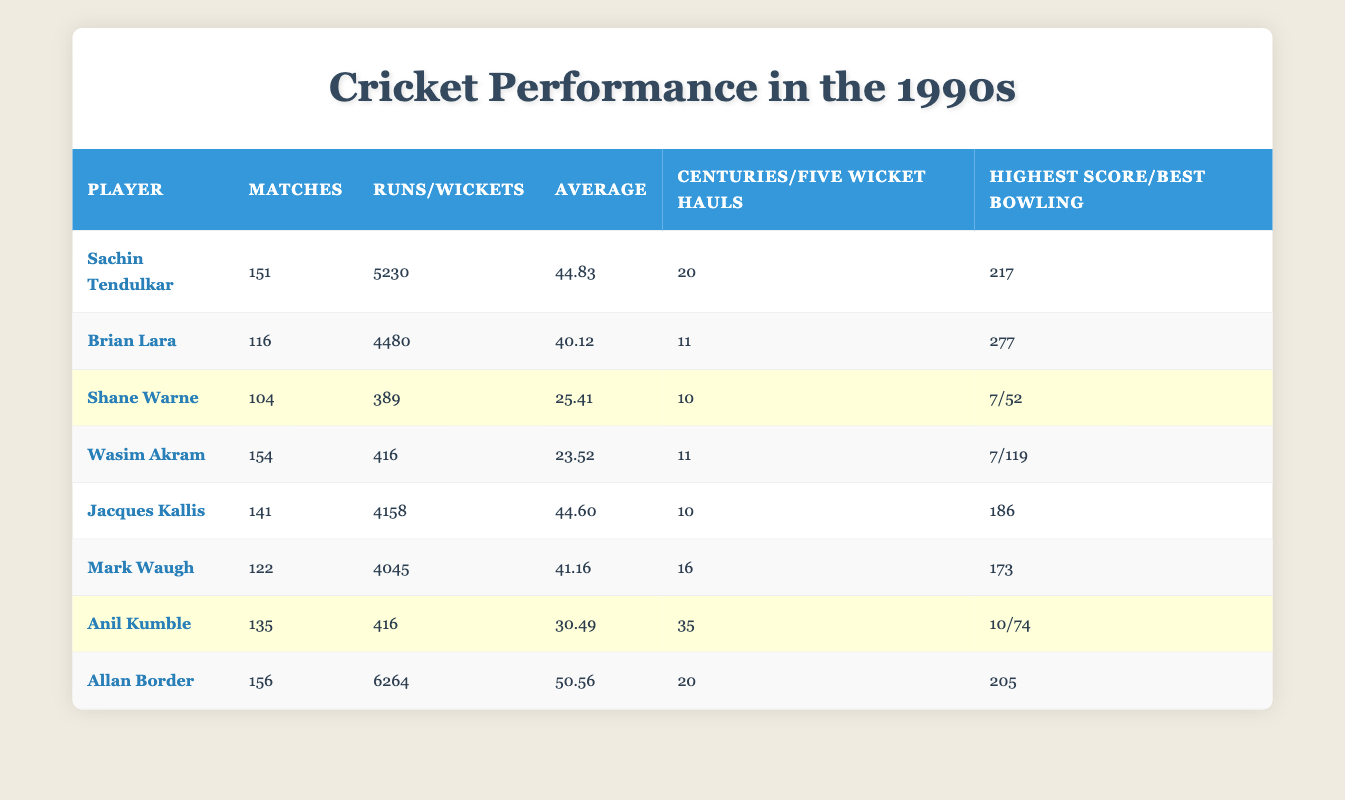What is the highest score achieved by Brian Lara? From the table, under the "Highest Score" column for Brian Lara, the value is listed as 277.
Answer: 277 Which player had the most five-wicket hauls in the 1990s? Referring to the "Five Wicket Hauls" column in the table, Anil Kumble had 35, which is the highest among all players listed.
Answer: Anil Kumble What is the total number of runs scored by Allan Border and Sachin Tendulkar combined? Adding the runs scored by Allan Border (6264) and Sachin Tendulkar (5230) gives (6264 + 5230) = 11494.
Answer: 11494 Is Jacques Kallis's batting average higher than that of Mark Waugh? Comparing the "Average" column values, Jacques Kallis has an average of 44.60, while Mark Waugh has 41.16. Since 44.60 is greater than 41.16, the statement is true.
Answer: Yes Who played more matches, Wasim Akram or Anil Kumble? Looking at the "Matches" column, Wasim Akram played 154 matches and Anil Kumble played 135 matches. Since 154 is greater than 135, Wasim Akram played more matches.
Answer: Wasim Akram What is the difference in wickets taken between Wasim Akram and Shane Warne? From the "Wickets" column, Wasim Akram took 416 wickets and Shane Warne took 389 wickets. The difference is (416 - 389) = 27.
Answer: 27 Did any player manage to reach a batting average of 50 or higher? Inspecting the "Average" column, Allan Border has an average of 50.56, which is above 50. Thus, the answer is yes.
Answer: Yes Which player has the highest number of centuries? In the "Centuries" column, both Allan Border and Sachin Tendulkar have achieved 20 centuries, but they do not exceed this number. Thus, the maximum is 20.
Answer: 20 Calculate the average number of runs scored by the players listed in the table. The total runs scored by all players is (5230 + 4480 + 4158 + 4045 + 6264) = 24177. There are 8 players total, thus the average is 24177/8 = 3022.125, approximately 3022.
Answer: 3022.125 How many players have a highest score greater than 200? Referring to the "Highest Score" column, both Sachin Tendulkar (217) and Allan Border (205) exceed 200. Therefore, there are two players.
Answer: 2 